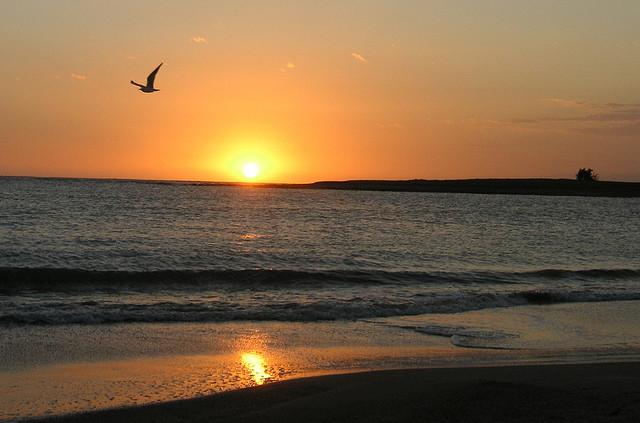What is shining bright in the background?
Quick response, please. Sun. Is it a cloudy day?
Keep it brief. No. Is the sun setting or rising?
Quick response, please. Setting. How many animals are visible?
Keep it brief. 1. Is this a port?
Be succinct. No. What is flying high in the sky?
Give a very brief answer. Bird. Is the water calm?
Give a very brief answer. Yes. 